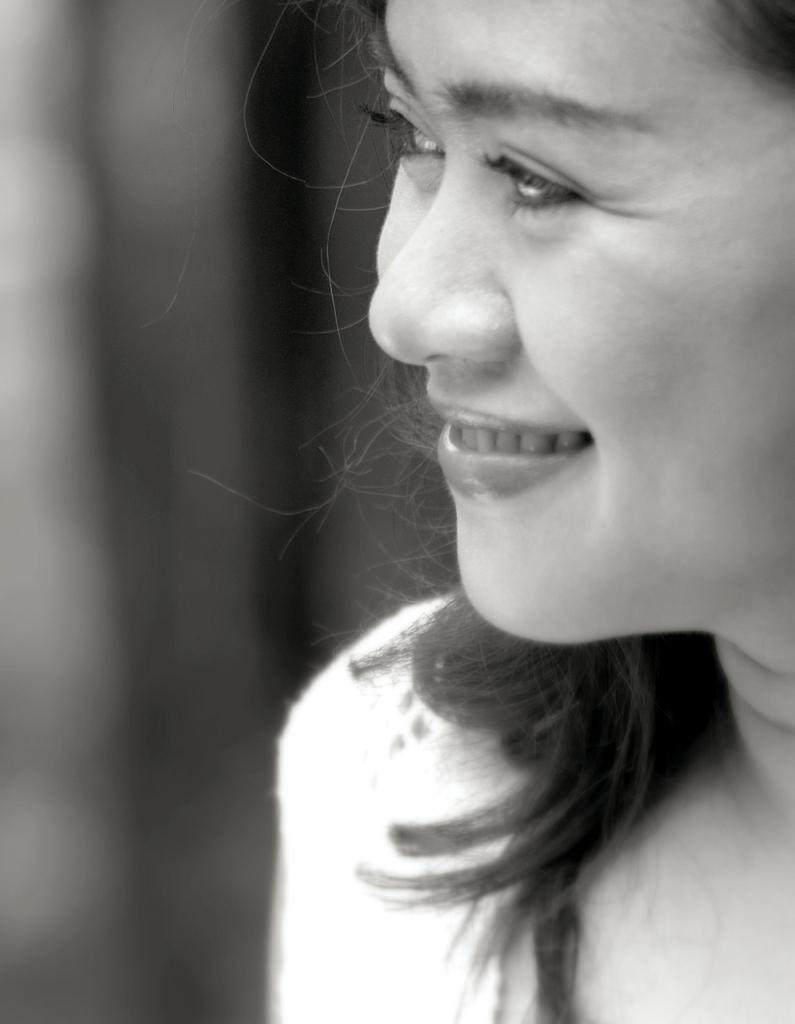What is the color scheme of the image? The image is black and white. What is the main subject of the image? There is a picture of a woman in the image. What type of dress is the woman wearing in the image? There is no dress visible in the image, as it is black and white and only features a picture of a woman. 